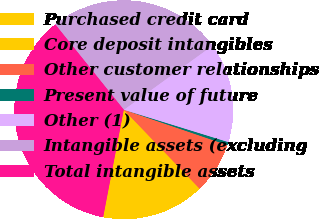<chart> <loc_0><loc_0><loc_500><loc_500><pie_chart><fcel>Purchased credit card<fcel>Core deposit intangibles<fcel>Other customer relationships<fcel>Present value of future<fcel>Other (1)<fcel>Intangible assets (excluding<fcel>Total intangible assets<nl><fcel>11.18%<fcel>4.02%<fcel>7.6%<fcel>0.45%<fcel>14.75%<fcel>25.79%<fcel>36.21%<nl></chart> 